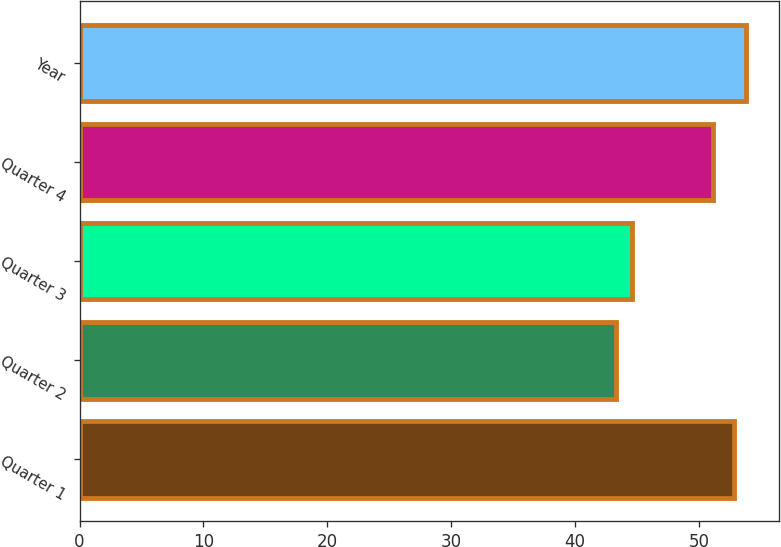Convert chart to OTSL. <chart><loc_0><loc_0><loc_500><loc_500><bar_chart><fcel>Quarter 1<fcel>Quarter 2<fcel>Quarter 3<fcel>Quarter 4<fcel>Year<nl><fcel>52.83<fcel>43.26<fcel>44.56<fcel>51.15<fcel>53.79<nl></chart> 